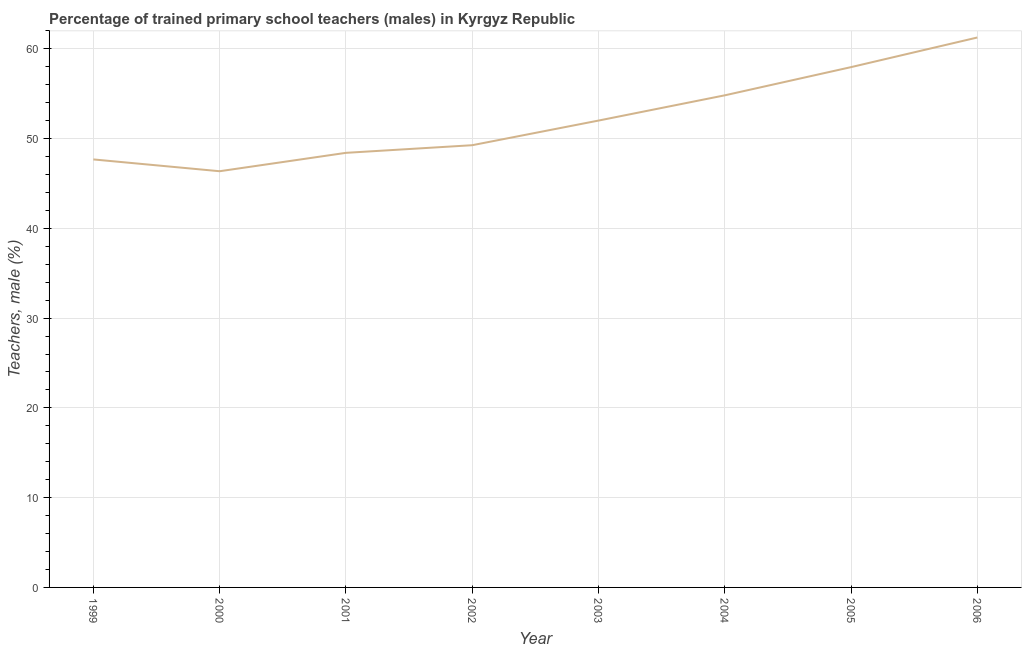What is the percentage of trained male teachers in 1999?
Offer a very short reply. 47.68. Across all years, what is the maximum percentage of trained male teachers?
Offer a very short reply. 61.26. Across all years, what is the minimum percentage of trained male teachers?
Offer a terse response. 46.36. In which year was the percentage of trained male teachers maximum?
Offer a very short reply. 2006. What is the sum of the percentage of trained male teachers?
Provide a succinct answer. 417.75. What is the difference between the percentage of trained male teachers in 2002 and 2005?
Give a very brief answer. -8.7. What is the average percentage of trained male teachers per year?
Give a very brief answer. 52.22. What is the median percentage of trained male teachers?
Provide a short and direct response. 50.63. What is the ratio of the percentage of trained male teachers in 1999 to that in 2005?
Offer a very short reply. 0.82. Is the percentage of trained male teachers in 1999 less than that in 2000?
Make the answer very short. No. What is the difference between the highest and the second highest percentage of trained male teachers?
Offer a terse response. 3.3. What is the difference between the highest and the lowest percentage of trained male teachers?
Provide a succinct answer. 14.9. In how many years, is the percentage of trained male teachers greater than the average percentage of trained male teachers taken over all years?
Your answer should be very brief. 3. Does the graph contain any zero values?
Give a very brief answer. No. Does the graph contain grids?
Offer a very short reply. Yes. What is the title of the graph?
Your response must be concise. Percentage of trained primary school teachers (males) in Kyrgyz Republic. What is the label or title of the Y-axis?
Provide a short and direct response. Teachers, male (%). What is the Teachers, male (%) of 1999?
Your answer should be compact. 47.68. What is the Teachers, male (%) in 2000?
Give a very brief answer. 46.36. What is the Teachers, male (%) of 2001?
Your answer should be compact. 48.41. What is the Teachers, male (%) of 2002?
Provide a short and direct response. 49.26. What is the Teachers, male (%) of 2003?
Your answer should be very brief. 52.01. What is the Teachers, male (%) of 2004?
Offer a very short reply. 54.82. What is the Teachers, male (%) in 2005?
Ensure brevity in your answer.  57.96. What is the Teachers, male (%) in 2006?
Your answer should be very brief. 61.26. What is the difference between the Teachers, male (%) in 1999 and 2000?
Your response must be concise. 1.32. What is the difference between the Teachers, male (%) in 1999 and 2001?
Keep it short and to the point. -0.73. What is the difference between the Teachers, male (%) in 1999 and 2002?
Keep it short and to the point. -1.58. What is the difference between the Teachers, male (%) in 1999 and 2003?
Your answer should be compact. -4.33. What is the difference between the Teachers, male (%) in 1999 and 2004?
Give a very brief answer. -7.14. What is the difference between the Teachers, male (%) in 1999 and 2005?
Your response must be concise. -10.28. What is the difference between the Teachers, male (%) in 1999 and 2006?
Offer a terse response. -13.58. What is the difference between the Teachers, male (%) in 2000 and 2001?
Offer a very short reply. -2.05. What is the difference between the Teachers, male (%) in 2000 and 2002?
Keep it short and to the point. -2.9. What is the difference between the Teachers, male (%) in 2000 and 2003?
Provide a short and direct response. -5.64. What is the difference between the Teachers, male (%) in 2000 and 2004?
Give a very brief answer. -8.45. What is the difference between the Teachers, male (%) in 2000 and 2005?
Your answer should be compact. -11.6. What is the difference between the Teachers, male (%) in 2000 and 2006?
Offer a very short reply. -14.9. What is the difference between the Teachers, male (%) in 2001 and 2002?
Provide a short and direct response. -0.85. What is the difference between the Teachers, male (%) in 2001 and 2003?
Your answer should be very brief. -3.59. What is the difference between the Teachers, male (%) in 2001 and 2004?
Give a very brief answer. -6.41. What is the difference between the Teachers, male (%) in 2001 and 2005?
Offer a very short reply. -9.55. What is the difference between the Teachers, male (%) in 2001 and 2006?
Provide a short and direct response. -12.85. What is the difference between the Teachers, male (%) in 2002 and 2003?
Ensure brevity in your answer.  -2.74. What is the difference between the Teachers, male (%) in 2002 and 2004?
Provide a short and direct response. -5.56. What is the difference between the Teachers, male (%) in 2002 and 2005?
Give a very brief answer. -8.7. What is the difference between the Teachers, male (%) in 2002 and 2006?
Provide a short and direct response. -12. What is the difference between the Teachers, male (%) in 2003 and 2004?
Your response must be concise. -2.81. What is the difference between the Teachers, male (%) in 2003 and 2005?
Offer a terse response. -5.95. What is the difference between the Teachers, male (%) in 2003 and 2006?
Provide a short and direct response. -9.25. What is the difference between the Teachers, male (%) in 2004 and 2005?
Your answer should be compact. -3.14. What is the difference between the Teachers, male (%) in 2004 and 2006?
Make the answer very short. -6.44. What is the difference between the Teachers, male (%) in 2005 and 2006?
Keep it short and to the point. -3.3. What is the ratio of the Teachers, male (%) in 1999 to that in 2000?
Your response must be concise. 1.03. What is the ratio of the Teachers, male (%) in 1999 to that in 2002?
Your response must be concise. 0.97. What is the ratio of the Teachers, male (%) in 1999 to that in 2003?
Make the answer very short. 0.92. What is the ratio of the Teachers, male (%) in 1999 to that in 2004?
Provide a short and direct response. 0.87. What is the ratio of the Teachers, male (%) in 1999 to that in 2005?
Keep it short and to the point. 0.82. What is the ratio of the Teachers, male (%) in 1999 to that in 2006?
Your response must be concise. 0.78. What is the ratio of the Teachers, male (%) in 2000 to that in 2001?
Make the answer very short. 0.96. What is the ratio of the Teachers, male (%) in 2000 to that in 2002?
Provide a succinct answer. 0.94. What is the ratio of the Teachers, male (%) in 2000 to that in 2003?
Provide a succinct answer. 0.89. What is the ratio of the Teachers, male (%) in 2000 to that in 2004?
Offer a terse response. 0.85. What is the ratio of the Teachers, male (%) in 2000 to that in 2005?
Your response must be concise. 0.8. What is the ratio of the Teachers, male (%) in 2000 to that in 2006?
Provide a succinct answer. 0.76. What is the ratio of the Teachers, male (%) in 2001 to that in 2002?
Your answer should be very brief. 0.98. What is the ratio of the Teachers, male (%) in 2001 to that in 2003?
Your response must be concise. 0.93. What is the ratio of the Teachers, male (%) in 2001 to that in 2004?
Your answer should be compact. 0.88. What is the ratio of the Teachers, male (%) in 2001 to that in 2005?
Make the answer very short. 0.83. What is the ratio of the Teachers, male (%) in 2001 to that in 2006?
Give a very brief answer. 0.79. What is the ratio of the Teachers, male (%) in 2002 to that in 2003?
Give a very brief answer. 0.95. What is the ratio of the Teachers, male (%) in 2002 to that in 2004?
Offer a terse response. 0.9. What is the ratio of the Teachers, male (%) in 2002 to that in 2006?
Your response must be concise. 0.8. What is the ratio of the Teachers, male (%) in 2003 to that in 2004?
Offer a terse response. 0.95. What is the ratio of the Teachers, male (%) in 2003 to that in 2005?
Give a very brief answer. 0.9. What is the ratio of the Teachers, male (%) in 2003 to that in 2006?
Offer a very short reply. 0.85. What is the ratio of the Teachers, male (%) in 2004 to that in 2005?
Keep it short and to the point. 0.95. What is the ratio of the Teachers, male (%) in 2004 to that in 2006?
Provide a succinct answer. 0.9. What is the ratio of the Teachers, male (%) in 2005 to that in 2006?
Provide a short and direct response. 0.95. 